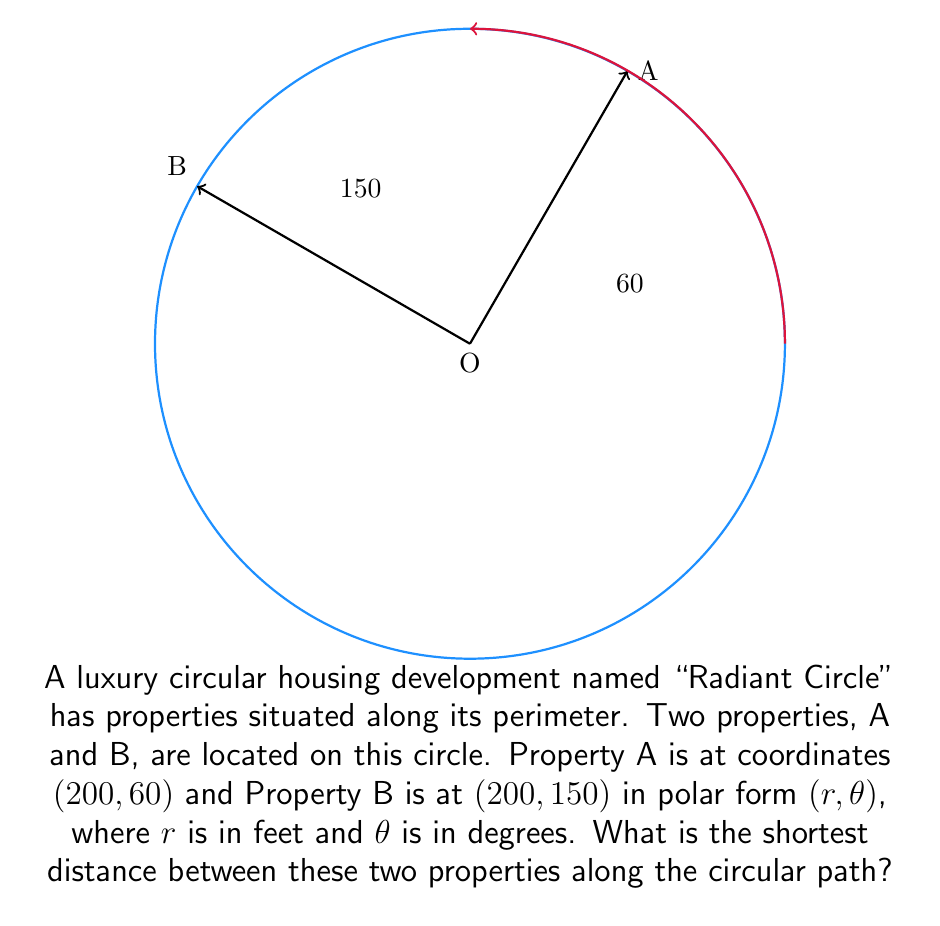Help me with this question. To solve this problem, we'll follow these steps:

1) In polar coordinates, the distance along an arc is calculated using the formula:
   $$s = r\theta$$
   where $s$ is the arc length, $r$ is the radius, and $\theta$ is the central angle in radians.

2) We're given the radius $r = 200$ feet for both properties.

3) The central angle is the difference between the angular coordinates:
   $$\theta = 150° - 60° = 90°$$

4) We need to convert this angle to radians:
   $$90° \times \frac{\pi}{180°} = \frac{\pi}{2} \text{ radians}$$

5) Now we can apply the arc length formula:
   $$s = r\theta = 200 \times \frac{\pi}{2} = 100\pi \text{ feet}$$

6) To get a decimal approximation:
   $$100\pi \approx 314.16 \text{ feet}$$
Answer: $100\pi$ feet (approximately 314.16 feet) 